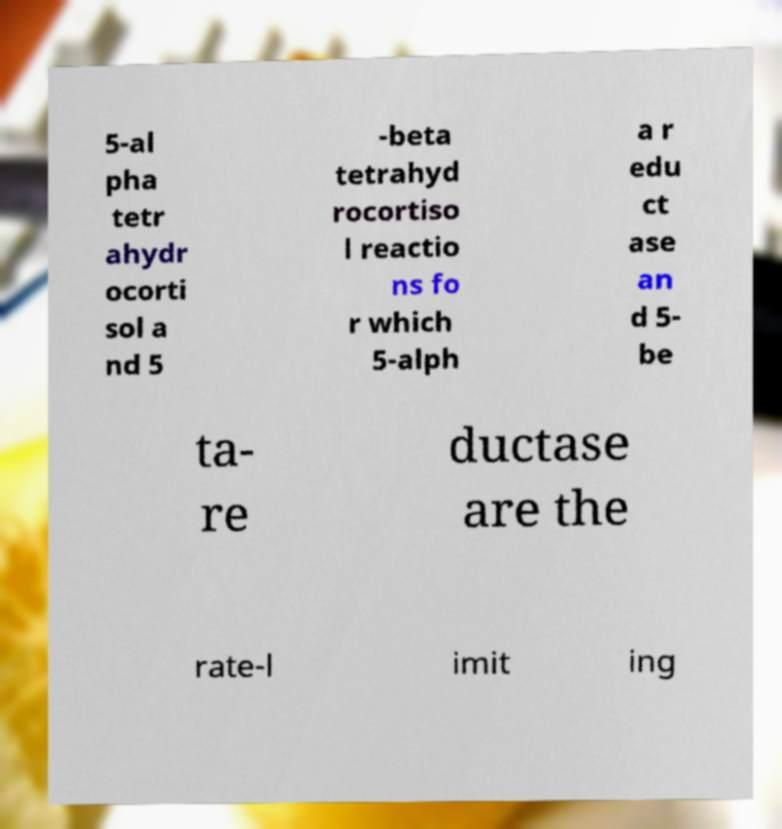Can you read and provide the text displayed in the image?This photo seems to have some interesting text. Can you extract and type it out for me? 5-al pha tetr ahydr ocorti sol a nd 5 -beta tetrahyd rocortiso l reactio ns fo r which 5-alph a r edu ct ase an d 5- be ta- re ductase are the rate-l imit ing 